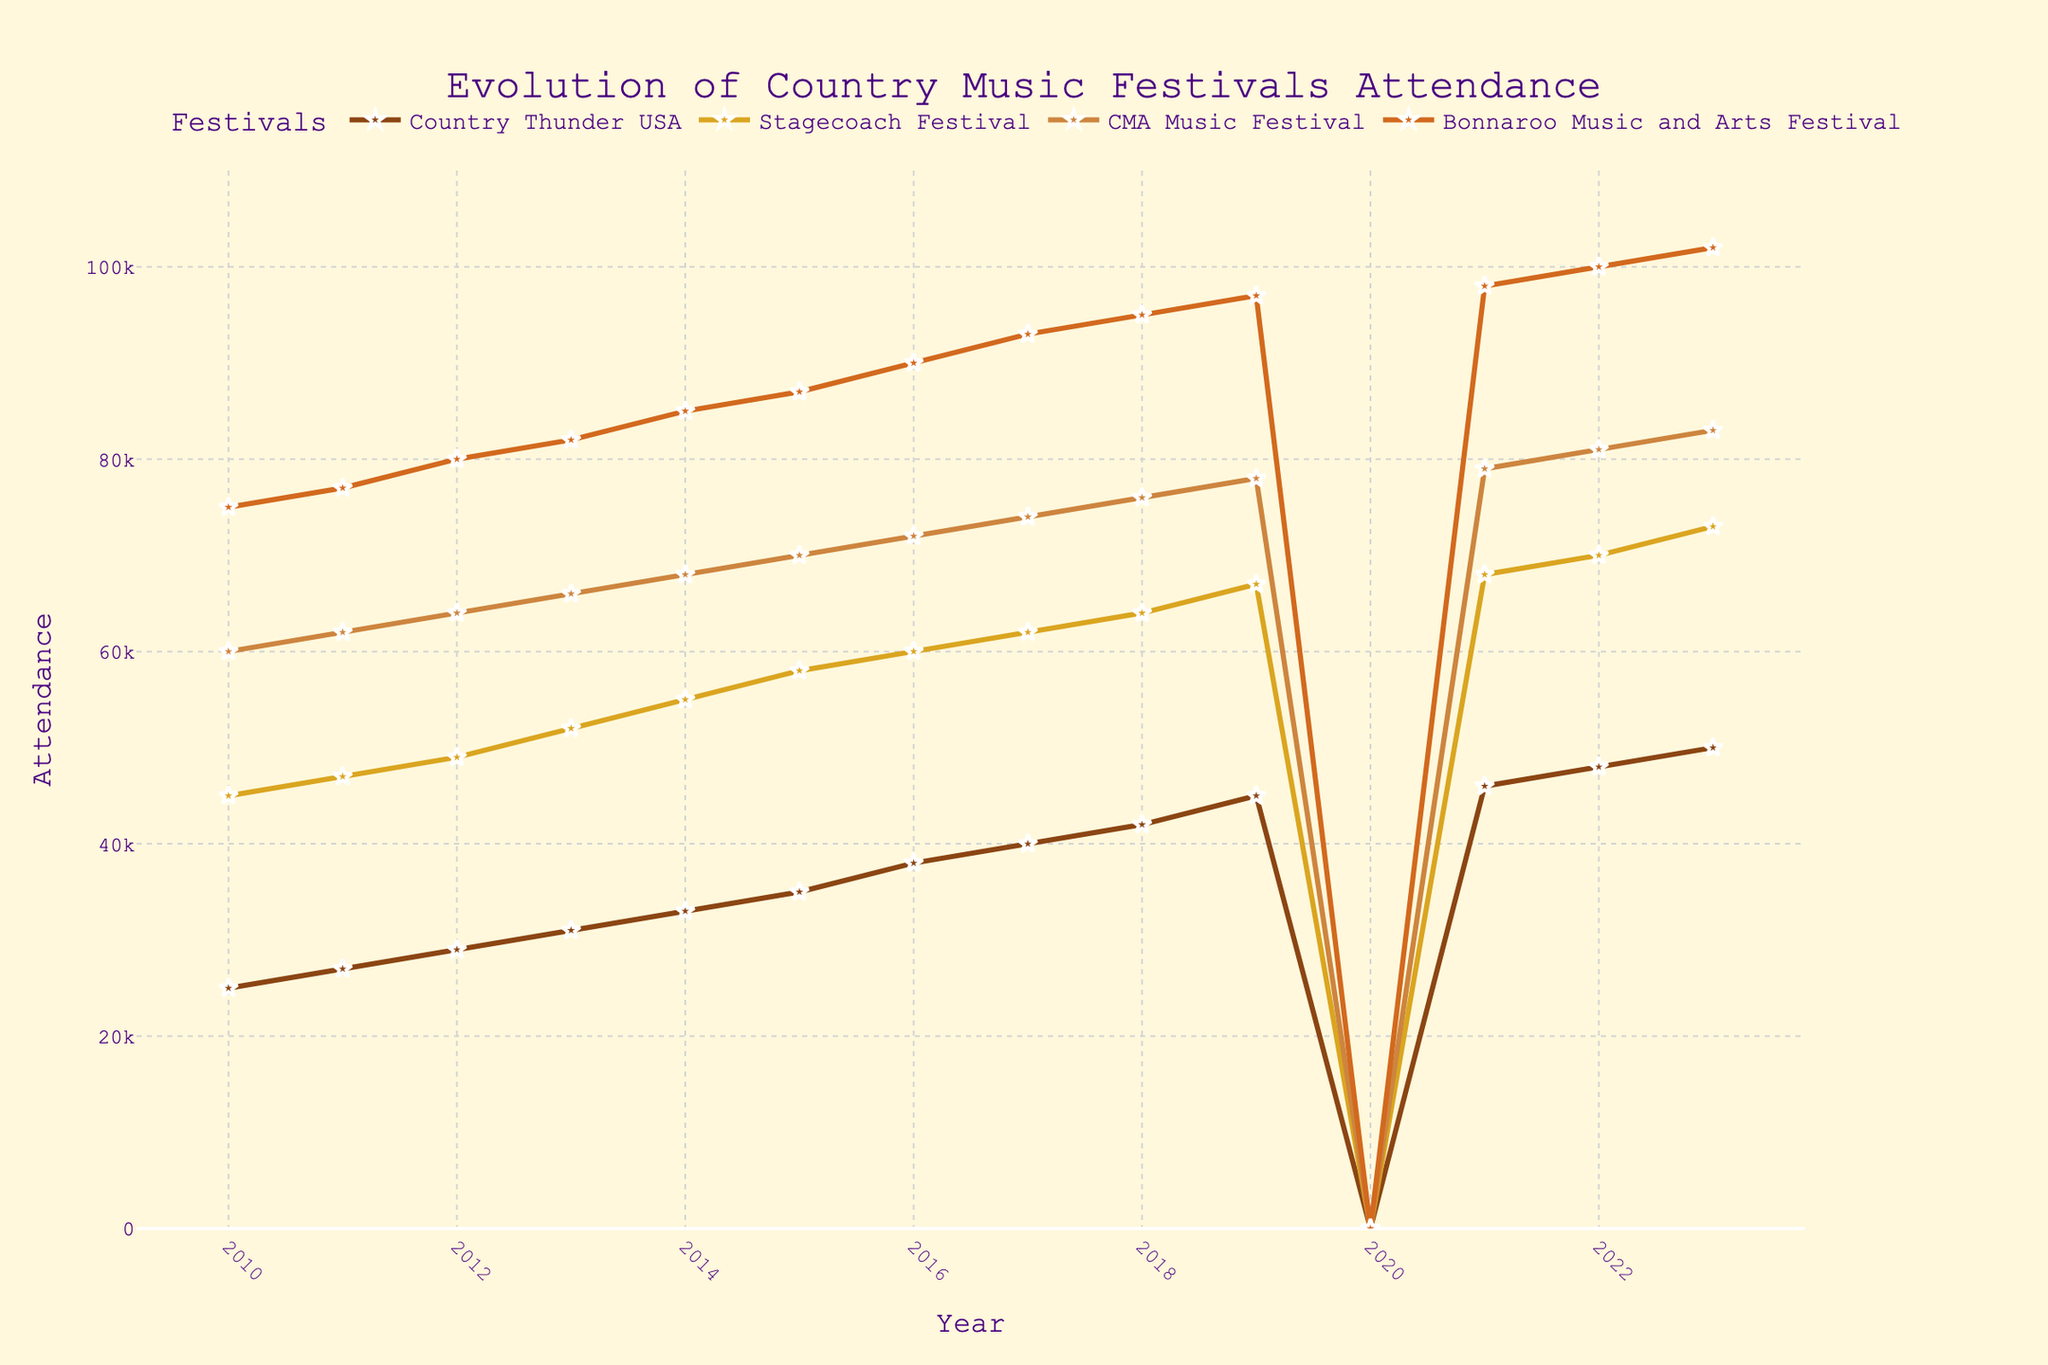What's the title of the figure? The title of the figure is displayed at the top and reads "Evolution of Country Music Festivals Attendance".
Answer: Evolution of Country Music Festivals Attendance What year had no attendance for all festivals? By observing the x-axis labels, we can find that the year with no data points plotted (y-values are zero) for all festivals is 2020.
Answer: 2020 Which festival had the highest attendance in 2013? By looking at the y-values of different colored lines for the year 2013, we see that the purple line, representing Bonnaroo Music and Arts Festival, has the highest value.
Answer: Bonnaroo Music and Arts Festival Between which years did the Country Thunder USA festival see the most significant increase in attendance? By examining the slope of the line representing Country Thunder USA (brown line), we can see the most significant jump is between 2019 and 2021, where it jumps from 45000 to 46000 (not possible due to 2020 being zero), therefore most significant increase is seen between 2011 to 2013.
Answer: 2011 to 2013 What is the average attendance for Stagecoach Festival from 2010 to 2023 (excluding 2020)? Sum the yearly attendance values from 2010 to 2023, excluding 2020 (45000 + 47000 + 49000 + 52000 + 55000 + 58000 + 60000 + 62000 + 64000 + 67000 + 68000 + 70000 + 73000) = 822000, then divide by the number of years (2023-2010+1-1 for 2020 = 13), 822000 / 13 = 63230.77
Answer: 63230.77 What was the difference in attendance between CMA Music Festival and Stagecoach Festival in 2018? For the year 2018, observe the data points on the y-axis for both festivals: CMA Music Festival is 76000, Stagecoach Festival is 64000. Calculate the difference: 76000 - 64000 = 12000.
Answer: 12000 How did the attendance of Bonnaroo Music and Arts Festival change from 2011 to 2023? Observe the y-values of the Bonnaroo Music and Arts Festival for these years: 2011: 77000, and 2023: 102000. Subtract the 2011 attendance from the 2023 attendance to find the change: 102000 - 77000 = 25000.
Answer: Increased by 25000 Which festival regained its attendance level the quickest after 2020? Comparing y-values from 2021, we find that the attendance figures for Bonnaroo Music and Arts Festival (98000), which is closest to its pre-2020 levels (97000 in 2019), demonstrate the quickest return to previous levels.
Answer: Bonnaroo Music and Arts Festival How many festivals surpassed the 80,000 attendance mark in 2023? Refer to the y-values for the year 2023: Country Thunder USA (50000), Stagecoach Festival (73000), CMA Music Festival (83000), Bonnaroo Music and Arts Festival (102000). Two surpassed 80,000: CMA Music Festival and Bonnaroo Music and Arts Festival.
Answer: 2 